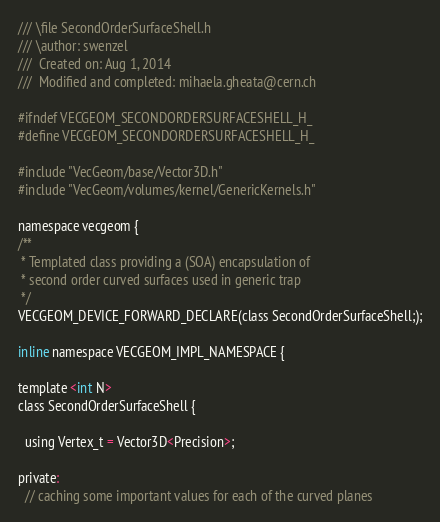Convert code to text. <code><loc_0><loc_0><loc_500><loc_500><_C_>/// \file SecondOrderSurfaceShell.h
/// \author: swenzel
///  Created on: Aug 1, 2014
///  Modified and completed: mihaela.gheata@cern.ch

#ifndef VECGEOM_SECONDORDERSURFACESHELL_H_
#define VECGEOM_SECONDORDERSURFACESHELL_H_

#include "VecGeom/base/Vector3D.h"
#include "VecGeom/volumes/kernel/GenericKernels.h"

namespace vecgeom {
/**
 * Templated class providing a (SOA) encapsulation of
 * second order curved surfaces used in generic trap
 */
VECGEOM_DEVICE_FORWARD_DECLARE(class SecondOrderSurfaceShell;);

inline namespace VECGEOM_IMPL_NAMESPACE {

template <int N>
class SecondOrderSurfaceShell {

  using Vertex_t = Vector3D<Precision>;

private:
  // caching some important values for each of the curved planes</code> 